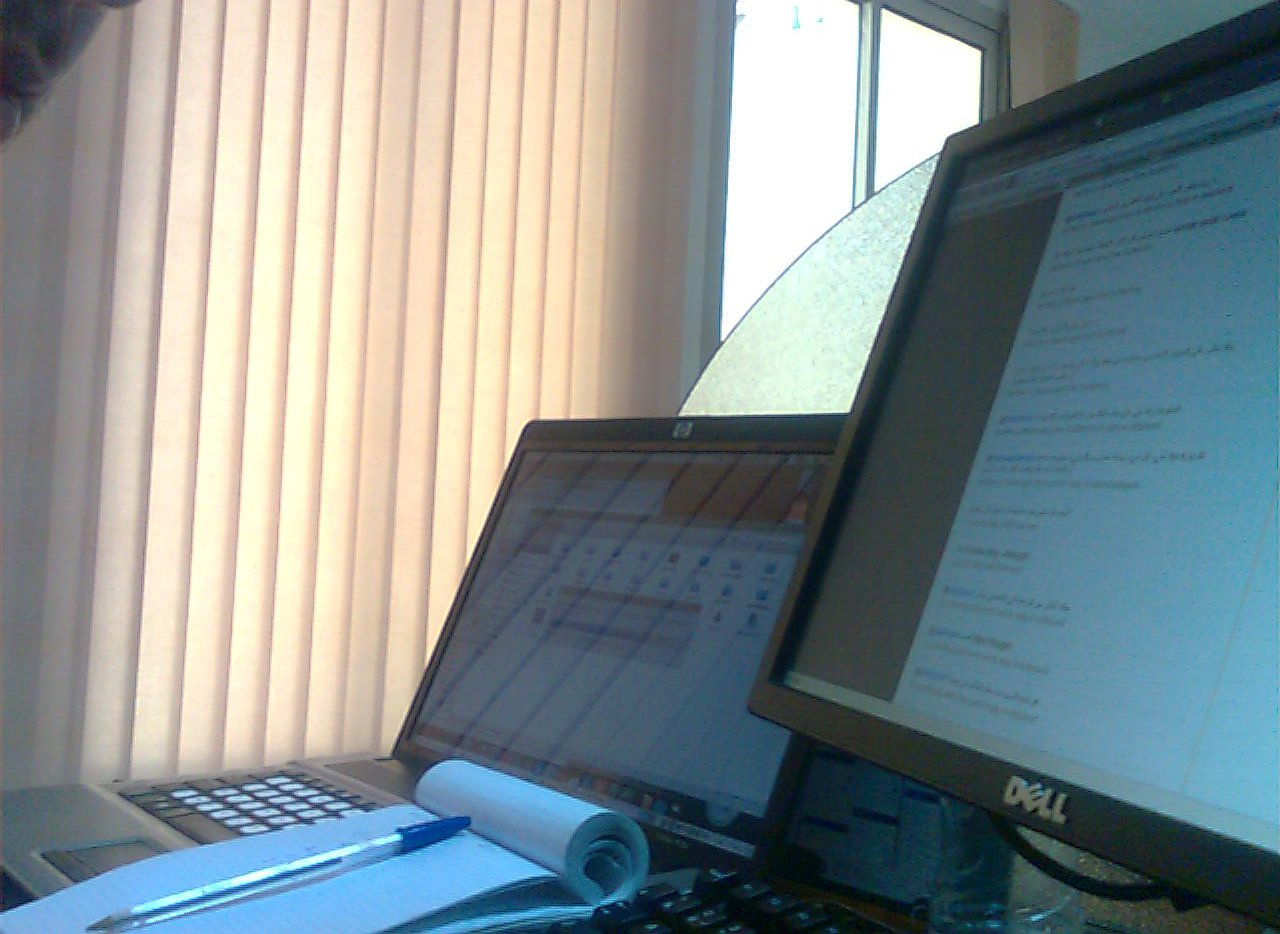What type of work might be done at this desk setup? This desk setup appears tailored for tasks that involve computing and light paperwork, such as administrative duties or data entry. 